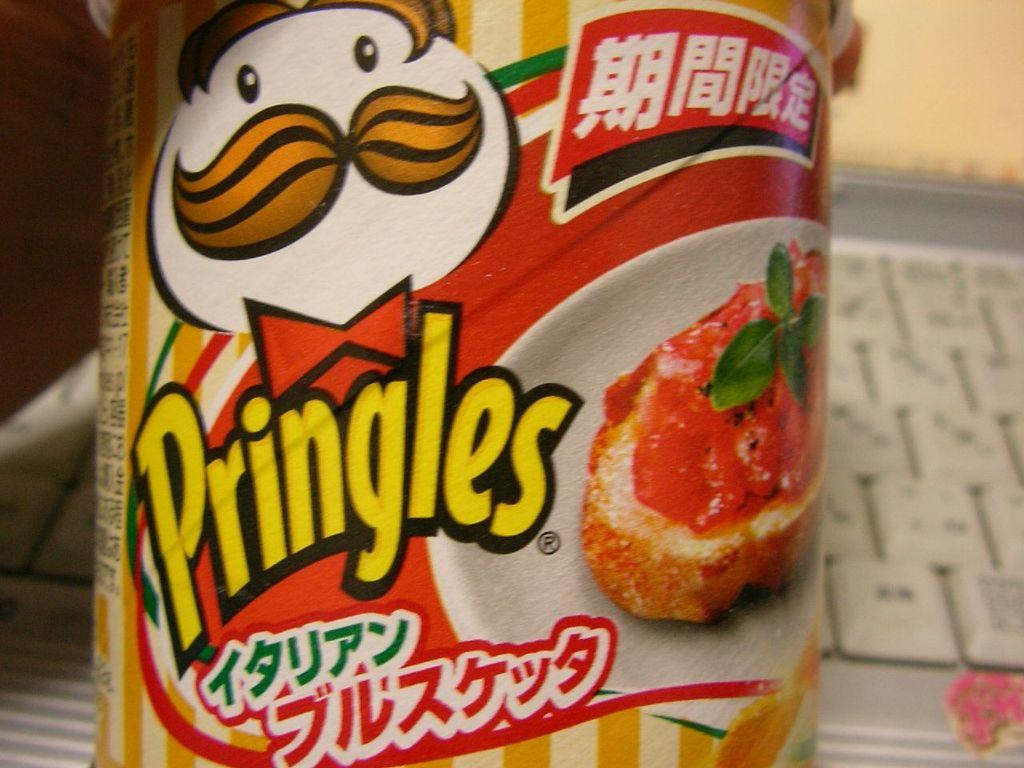What object is present in the image that has a face on it? There is a box in the image that has an animated character face on it. What can be found on the box besides the face? There are words on the box. What type of food is visible in the image? There is food in the image. Can you describe the background of the image? The background is blurred. What country is the invention from that is featured in the image? There is no invention or country mentioned in the image; it only features a box with an animated character face and food. 